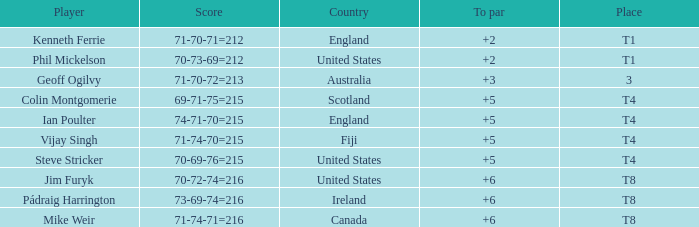Who had a score of 70-73-69=212? Phil Mickelson. 